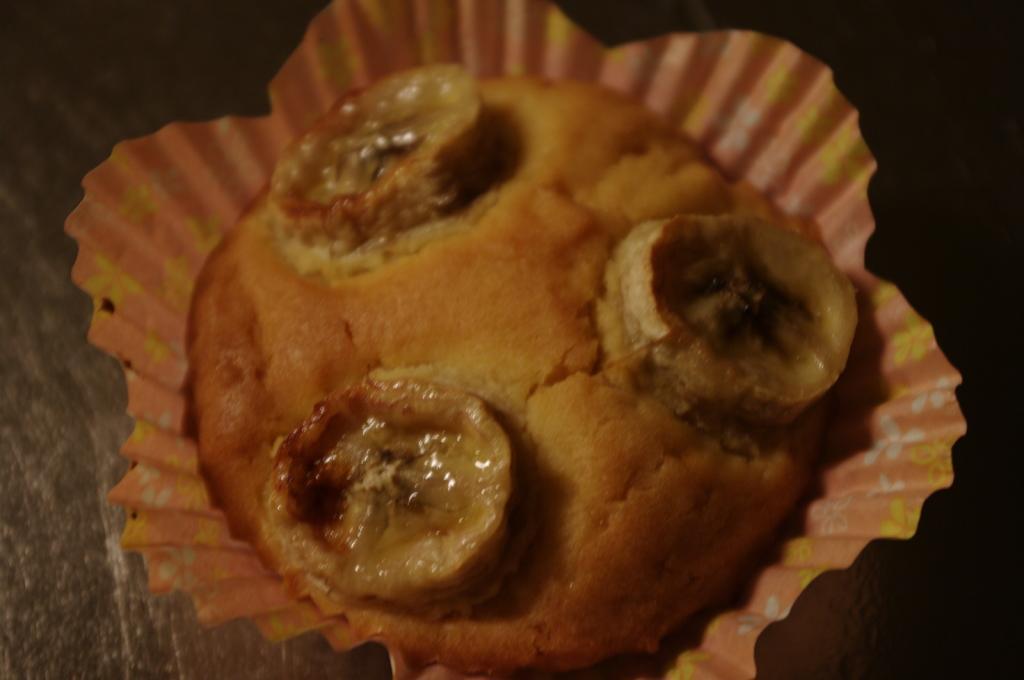Describe this image in one or two sentences. In this image I can see a cup cake which is brown and cream in color in a cup which is orange, white and yellow in color. I can see it is on the black colored surface. 